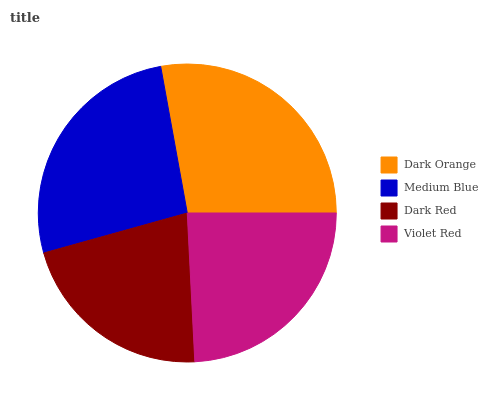Is Dark Red the minimum?
Answer yes or no. Yes. Is Dark Orange the maximum?
Answer yes or no. Yes. Is Medium Blue the minimum?
Answer yes or no. No. Is Medium Blue the maximum?
Answer yes or no. No. Is Dark Orange greater than Medium Blue?
Answer yes or no. Yes. Is Medium Blue less than Dark Orange?
Answer yes or no. Yes. Is Medium Blue greater than Dark Orange?
Answer yes or no. No. Is Dark Orange less than Medium Blue?
Answer yes or no. No. Is Medium Blue the high median?
Answer yes or no. Yes. Is Violet Red the low median?
Answer yes or no. Yes. Is Dark Orange the high median?
Answer yes or no. No. Is Dark Orange the low median?
Answer yes or no. No. 